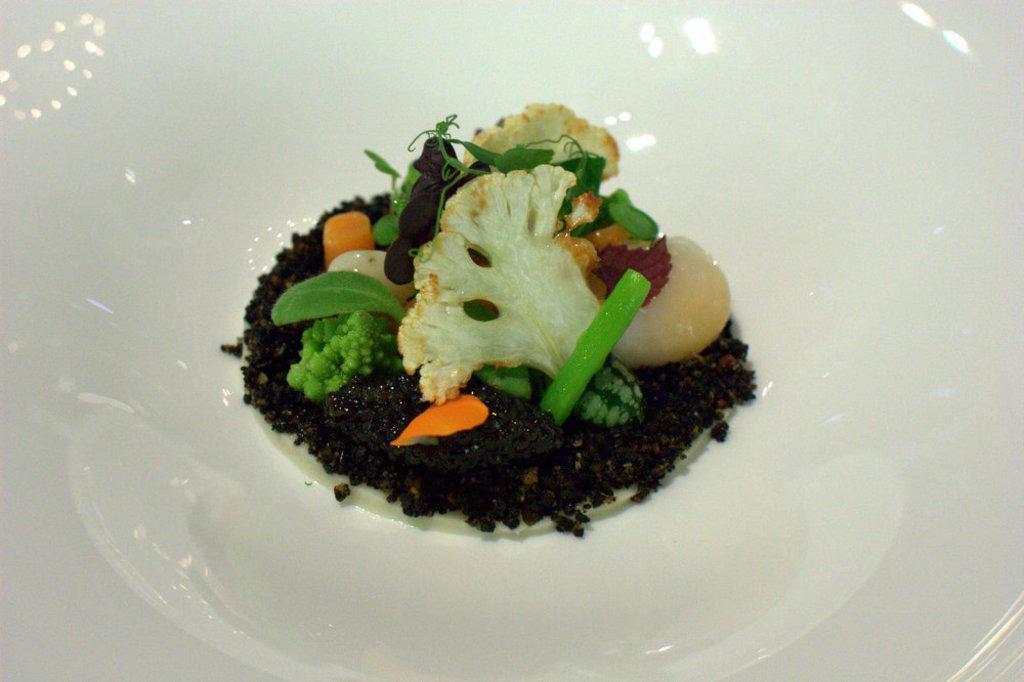Describe this image in one or two sentences. In the image we can see a bowl, white in color. In the bowl we can see there is a food item. 